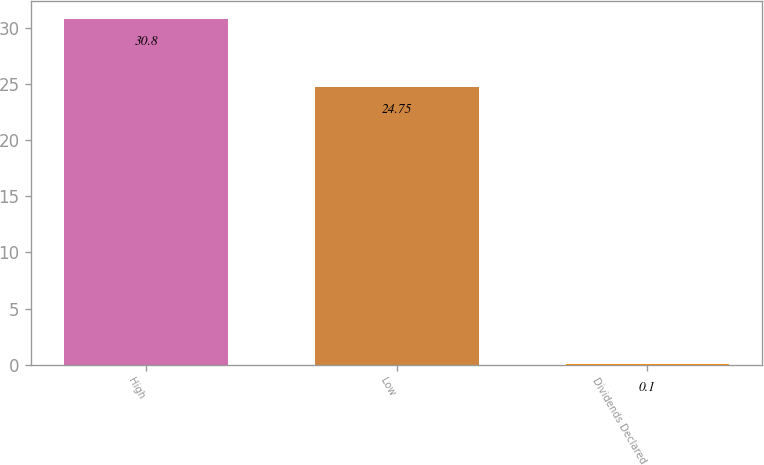<chart> <loc_0><loc_0><loc_500><loc_500><bar_chart><fcel>High<fcel>Low<fcel>Dividends Declared<nl><fcel>30.8<fcel>24.75<fcel>0.1<nl></chart> 